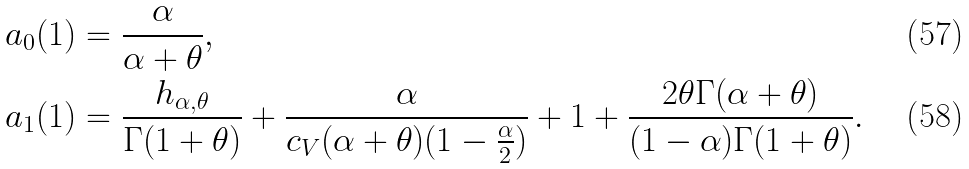<formula> <loc_0><loc_0><loc_500><loc_500>a _ { 0 } ( 1 ) & = \frac { \alpha } { \alpha + \theta } , \\ a _ { 1 } ( 1 ) & = \frac { h _ { \alpha , \theta } } { \Gamma ( 1 + \theta ) } + \frac { \alpha } { c _ { V } ( \alpha + \theta ) ( 1 - \frac { \alpha } { 2 } ) } + 1 + \frac { 2 \theta \Gamma ( \alpha + \theta ) } { ( 1 - \alpha ) \Gamma ( 1 + \theta ) } .</formula> 